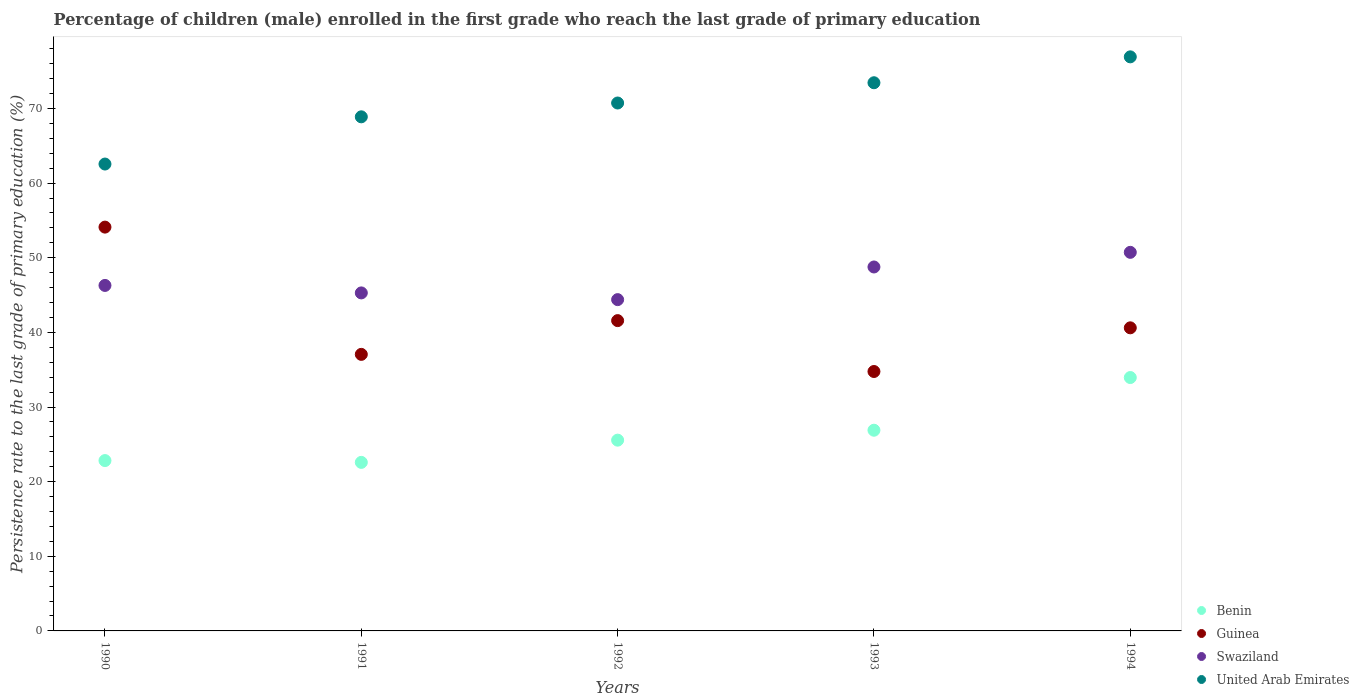Is the number of dotlines equal to the number of legend labels?
Your answer should be very brief. Yes. What is the persistence rate of children in Guinea in 1994?
Provide a short and direct response. 40.61. Across all years, what is the maximum persistence rate of children in Swaziland?
Your answer should be very brief. 50.73. Across all years, what is the minimum persistence rate of children in United Arab Emirates?
Give a very brief answer. 62.56. What is the total persistence rate of children in Swaziland in the graph?
Provide a short and direct response. 235.47. What is the difference between the persistence rate of children in Benin in 1991 and that in 1994?
Provide a short and direct response. -11.37. What is the difference between the persistence rate of children in Guinea in 1991 and the persistence rate of children in Benin in 1992?
Provide a succinct answer. 11.49. What is the average persistence rate of children in Swaziland per year?
Offer a terse response. 47.09. In the year 1992, what is the difference between the persistence rate of children in United Arab Emirates and persistence rate of children in Swaziland?
Ensure brevity in your answer.  26.35. In how many years, is the persistence rate of children in Guinea greater than 38 %?
Make the answer very short. 3. What is the ratio of the persistence rate of children in United Arab Emirates in 1990 to that in 1991?
Provide a succinct answer. 0.91. Is the difference between the persistence rate of children in United Arab Emirates in 1990 and 1994 greater than the difference between the persistence rate of children in Swaziland in 1990 and 1994?
Ensure brevity in your answer.  No. What is the difference between the highest and the second highest persistence rate of children in Swaziland?
Provide a short and direct response. 1.96. What is the difference between the highest and the lowest persistence rate of children in Swaziland?
Provide a short and direct response. 6.34. In how many years, is the persistence rate of children in Guinea greater than the average persistence rate of children in Guinea taken over all years?
Offer a very short reply. 1. Is it the case that in every year, the sum of the persistence rate of children in United Arab Emirates and persistence rate of children in Swaziland  is greater than the persistence rate of children in Guinea?
Provide a succinct answer. Yes. Does the persistence rate of children in Benin monotonically increase over the years?
Provide a succinct answer. No. Is the persistence rate of children in United Arab Emirates strictly less than the persistence rate of children in Swaziland over the years?
Offer a very short reply. No. How many years are there in the graph?
Your answer should be very brief. 5. Does the graph contain grids?
Your response must be concise. No. Where does the legend appear in the graph?
Your response must be concise. Bottom right. How are the legend labels stacked?
Your answer should be compact. Vertical. What is the title of the graph?
Ensure brevity in your answer.  Percentage of children (male) enrolled in the first grade who reach the last grade of primary education. What is the label or title of the X-axis?
Your answer should be very brief. Years. What is the label or title of the Y-axis?
Your response must be concise. Persistence rate to the last grade of primary education (%). What is the Persistence rate to the last grade of primary education (%) in Benin in 1990?
Ensure brevity in your answer.  22.82. What is the Persistence rate to the last grade of primary education (%) of Guinea in 1990?
Keep it short and to the point. 54.11. What is the Persistence rate to the last grade of primary education (%) of Swaziland in 1990?
Your answer should be compact. 46.29. What is the Persistence rate to the last grade of primary education (%) of United Arab Emirates in 1990?
Your answer should be very brief. 62.56. What is the Persistence rate to the last grade of primary education (%) in Benin in 1991?
Your answer should be very brief. 22.58. What is the Persistence rate to the last grade of primary education (%) of Guinea in 1991?
Make the answer very short. 37.06. What is the Persistence rate to the last grade of primary education (%) in Swaziland in 1991?
Provide a short and direct response. 45.29. What is the Persistence rate to the last grade of primary education (%) in United Arab Emirates in 1991?
Offer a terse response. 68.89. What is the Persistence rate to the last grade of primary education (%) in Benin in 1992?
Your answer should be compact. 25.56. What is the Persistence rate to the last grade of primary education (%) of Guinea in 1992?
Offer a very short reply. 41.58. What is the Persistence rate to the last grade of primary education (%) of Swaziland in 1992?
Offer a very short reply. 44.39. What is the Persistence rate to the last grade of primary education (%) of United Arab Emirates in 1992?
Offer a terse response. 70.74. What is the Persistence rate to the last grade of primary education (%) in Benin in 1993?
Give a very brief answer. 26.89. What is the Persistence rate to the last grade of primary education (%) of Guinea in 1993?
Keep it short and to the point. 34.76. What is the Persistence rate to the last grade of primary education (%) in Swaziland in 1993?
Provide a succinct answer. 48.76. What is the Persistence rate to the last grade of primary education (%) in United Arab Emirates in 1993?
Offer a terse response. 73.45. What is the Persistence rate to the last grade of primary education (%) in Benin in 1994?
Offer a terse response. 33.95. What is the Persistence rate to the last grade of primary education (%) of Guinea in 1994?
Keep it short and to the point. 40.61. What is the Persistence rate to the last grade of primary education (%) in Swaziland in 1994?
Your response must be concise. 50.73. What is the Persistence rate to the last grade of primary education (%) in United Arab Emirates in 1994?
Provide a short and direct response. 76.92. Across all years, what is the maximum Persistence rate to the last grade of primary education (%) in Benin?
Keep it short and to the point. 33.95. Across all years, what is the maximum Persistence rate to the last grade of primary education (%) in Guinea?
Your response must be concise. 54.11. Across all years, what is the maximum Persistence rate to the last grade of primary education (%) of Swaziland?
Keep it short and to the point. 50.73. Across all years, what is the maximum Persistence rate to the last grade of primary education (%) in United Arab Emirates?
Provide a succinct answer. 76.92. Across all years, what is the minimum Persistence rate to the last grade of primary education (%) of Benin?
Offer a terse response. 22.58. Across all years, what is the minimum Persistence rate to the last grade of primary education (%) in Guinea?
Make the answer very short. 34.76. Across all years, what is the minimum Persistence rate to the last grade of primary education (%) in Swaziland?
Your answer should be compact. 44.39. Across all years, what is the minimum Persistence rate to the last grade of primary education (%) in United Arab Emirates?
Offer a very short reply. 62.56. What is the total Persistence rate to the last grade of primary education (%) in Benin in the graph?
Ensure brevity in your answer.  131.81. What is the total Persistence rate to the last grade of primary education (%) in Guinea in the graph?
Your answer should be compact. 208.11. What is the total Persistence rate to the last grade of primary education (%) in Swaziland in the graph?
Your answer should be compact. 235.47. What is the total Persistence rate to the last grade of primary education (%) of United Arab Emirates in the graph?
Make the answer very short. 352.55. What is the difference between the Persistence rate to the last grade of primary education (%) of Benin in 1990 and that in 1991?
Your response must be concise. 0.24. What is the difference between the Persistence rate to the last grade of primary education (%) of Guinea in 1990 and that in 1991?
Keep it short and to the point. 17.05. What is the difference between the Persistence rate to the last grade of primary education (%) in United Arab Emirates in 1990 and that in 1991?
Provide a succinct answer. -6.33. What is the difference between the Persistence rate to the last grade of primary education (%) of Benin in 1990 and that in 1992?
Offer a terse response. -2.74. What is the difference between the Persistence rate to the last grade of primary education (%) in Guinea in 1990 and that in 1992?
Your answer should be very brief. 12.53. What is the difference between the Persistence rate to the last grade of primary education (%) of Swaziland in 1990 and that in 1992?
Your answer should be compact. 1.9. What is the difference between the Persistence rate to the last grade of primary education (%) of United Arab Emirates in 1990 and that in 1992?
Provide a short and direct response. -8.18. What is the difference between the Persistence rate to the last grade of primary education (%) in Benin in 1990 and that in 1993?
Give a very brief answer. -4.07. What is the difference between the Persistence rate to the last grade of primary education (%) in Guinea in 1990 and that in 1993?
Offer a very short reply. 19.35. What is the difference between the Persistence rate to the last grade of primary education (%) of Swaziland in 1990 and that in 1993?
Keep it short and to the point. -2.47. What is the difference between the Persistence rate to the last grade of primary education (%) in United Arab Emirates in 1990 and that in 1993?
Your response must be concise. -10.89. What is the difference between the Persistence rate to the last grade of primary education (%) of Benin in 1990 and that in 1994?
Provide a short and direct response. -11.13. What is the difference between the Persistence rate to the last grade of primary education (%) in Guinea in 1990 and that in 1994?
Offer a terse response. 13.49. What is the difference between the Persistence rate to the last grade of primary education (%) in Swaziland in 1990 and that in 1994?
Make the answer very short. -4.44. What is the difference between the Persistence rate to the last grade of primary education (%) of United Arab Emirates in 1990 and that in 1994?
Offer a terse response. -14.36. What is the difference between the Persistence rate to the last grade of primary education (%) in Benin in 1991 and that in 1992?
Offer a very short reply. -2.98. What is the difference between the Persistence rate to the last grade of primary education (%) of Guinea in 1991 and that in 1992?
Ensure brevity in your answer.  -4.52. What is the difference between the Persistence rate to the last grade of primary education (%) of Swaziland in 1991 and that in 1992?
Give a very brief answer. 0.9. What is the difference between the Persistence rate to the last grade of primary education (%) of United Arab Emirates in 1991 and that in 1992?
Offer a very short reply. -1.85. What is the difference between the Persistence rate to the last grade of primary education (%) in Benin in 1991 and that in 1993?
Make the answer very short. -4.31. What is the difference between the Persistence rate to the last grade of primary education (%) in Guinea in 1991 and that in 1993?
Your answer should be compact. 2.3. What is the difference between the Persistence rate to the last grade of primary education (%) in Swaziland in 1991 and that in 1993?
Provide a succinct answer. -3.47. What is the difference between the Persistence rate to the last grade of primary education (%) in United Arab Emirates in 1991 and that in 1993?
Keep it short and to the point. -4.57. What is the difference between the Persistence rate to the last grade of primary education (%) of Benin in 1991 and that in 1994?
Provide a short and direct response. -11.37. What is the difference between the Persistence rate to the last grade of primary education (%) in Guinea in 1991 and that in 1994?
Give a very brief answer. -3.56. What is the difference between the Persistence rate to the last grade of primary education (%) in Swaziland in 1991 and that in 1994?
Keep it short and to the point. -5.44. What is the difference between the Persistence rate to the last grade of primary education (%) in United Arab Emirates in 1991 and that in 1994?
Offer a terse response. -8.04. What is the difference between the Persistence rate to the last grade of primary education (%) of Benin in 1992 and that in 1993?
Offer a very short reply. -1.33. What is the difference between the Persistence rate to the last grade of primary education (%) in Guinea in 1992 and that in 1993?
Offer a terse response. 6.82. What is the difference between the Persistence rate to the last grade of primary education (%) of Swaziland in 1992 and that in 1993?
Your answer should be very brief. -4.37. What is the difference between the Persistence rate to the last grade of primary education (%) in United Arab Emirates in 1992 and that in 1993?
Offer a terse response. -2.71. What is the difference between the Persistence rate to the last grade of primary education (%) in Benin in 1992 and that in 1994?
Make the answer very short. -8.39. What is the difference between the Persistence rate to the last grade of primary education (%) of Guinea in 1992 and that in 1994?
Your answer should be compact. 0.97. What is the difference between the Persistence rate to the last grade of primary education (%) in Swaziland in 1992 and that in 1994?
Offer a terse response. -6.34. What is the difference between the Persistence rate to the last grade of primary education (%) in United Arab Emirates in 1992 and that in 1994?
Your answer should be compact. -6.18. What is the difference between the Persistence rate to the last grade of primary education (%) in Benin in 1993 and that in 1994?
Make the answer very short. -7.06. What is the difference between the Persistence rate to the last grade of primary education (%) in Guinea in 1993 and that in 1994?
Keep it short and to the point. -5.85. What is the difference between the Persistence rate to the last grade of primary education (%) in Swaziland in 1993 and that in 1994?
Provide a short and direct response. -1.96. What is the difference between the Persistence rate to the last grade of primary education (%) of United Arab Emirates in 1993 and that in 1994?
Your response must be concise. -3.47. What is the difference between the Persistence rate to the last grade of primary education (%) in Benin in 1990 and the Persistence rate to the last grade of primary education (%) in Guinea in 1991?
Your answer should be very brief. -14.23. What is the difference between the Persistence rate to the last grade of primary education (%) of Benin in 1990 and the Persistence rate to the last grade of primary education (%) of Swaziland in 1991?
Give a very brief answer. -22.47. What is the difference between the Persistence rate to the last grade of primary education (%) of Benin in 1990 and the Persistence rate to the last grade of primary education (%) of United Arab Emirates in 1991?
Give a very brief answer. -46.06. What is the difference between the Persistence rate to the last grade of primary education (%) of Guinea in 1990 and the Persistence rate to the last grade of primary education (%) of Swaziland in 1991?
Make the answer very short. 8.82. What is the difference between the Persistence rate to the last grade of primary education (%) of Guinea in 1990 and the Persistence rate to the last grade of primary education (%) of United Arab Emirates in 1991?
Your answer should be compact. -14.78. What is the difference between the Persistence rate to the last grade of primary education (%) in Swaziland in 1990 and the Persistence rate to the last grade of primary education (%) in United Arab Emirates in 1991?
Your answer should be compact. -22.59. What is the difference between the Persistence rate to the last grade of primary education (%) of Benin in 1990 and the Persistence rate to the last grade of primary education (%) of Guinea in 1992?
Provide a short and direct response. -18.75. What is the difference between the Persistence rate to the last grade of primary education (%) in Benin in 1990 and the Persistence rate to the last grade of primary education (%) in Swaziland in 1992?
Keep it short and to the point. -21.57. What is the difference between the Persistence rate to the last grade of primary education (%) in Benin in 1990 and the Persistence rate to the last grade of primary education (%) in United Arab Emirates in 1992?
Make the answer very short. -47.91. What is the difference between the Persistence rate to the last grade of primary education (%) in Guinea in 1990 and the Persistence rate to the last grade of primary education (%) in Swaziland in 1992?
Provide a short and direct response. 9.72. What is the difference between the Persistence rate to the last grade of primary education (%) of Guinea in 1990 and the Persistence rate to the last grade of primary education (%) of United Arab Emirates in 1992?
Offer a terse response. -16.63. What is the difference between the Persistence rate to the last grade of primary education (%) of Swaziland in 1990 and the Persistence rate to the last grade of primary education (%) of United Arab Emirates in 1992?
Offer a terse response. -24.44. What is the difference between the Persistence rate to the last grade of primary education (%) in Benin in 1990 and the Persistence rate to the last grade of primary education (%) in Guinea in 1993?
Provide a short and direct response. -11.94. What is the difference between the Persistence rate to the last grade of primary education (%) of Benin in 1990 and the Persistence rate to the last grade of primary education (%) of Swaziland in 1993?
Keep it short and to the point. -25.94. What is the difference between the Persistence rate to the last grade of primary education (%) of Benin in 1990 and the Persistence rate to the last grade of primary education (%) of United Arab Emirates in 1993?
Give a very brief answer. -50.63. What is the difference between the Persistence rate to the last grade of primary education (%) in Guinea in 1990 and the Persistence rate to the last grade of primary education (%) in Swaziland in 1993?
Your response must be concise. 5.34. What is the difference between the Persistence rate to the last grade of primary education (%) of Guinea in 1990 and the Persistence rate to the last grade of primary education (%) of United Arab Emirates in 1993?
Keep it short and to the point. -19.34. What is the difference between the Persistence rate to the last grade of primary education (%) of Swaziland in 1990 and the Persistence rate to the last grade of primary education (%) of United Arab Emirates in 1993?
Give a very brief answer. -27.16. What is the difference between the Persistence rate to the last grade of primary education (%) of Benin in 1990 and the Persistence rate to the last grade of primary education (%) of Guinea in 1994?
Provide a succinct answer. -17.79. What is the difference between the Persistence rate to the last grade of primary education (%) in Benin in 1990 and the Persistence rate to the last grade of primary education (%) in Swaziland in 1994?
Your answer should be very brief. -27.9. What is the difference between the Persistence rate to the last grade of primary education (%) of Benin in 1990 and the Persistence rate to the last grade of primary education (%) of United Arab Emirates in 1994?
Ensure brevity in your answer.  -54.1. What is the difference between the Persistence rate to the last grade of primary education (%) of Guinea in 1990 and the Persistence rate to the last grade of primary education (%) of Swaziland in 1994?
Provide a succinct answer. 3.38. What is the difference between the Persistence rate to the last grade of primary education (%) in Guinea in 1990 and the Persistence rate to the last grade of primary education (%) in United Arab Emirates in 1994?
Make the answer very short. -22.81. What is the difference between the Persistence rate to the last grade of primary education (%) in Swaziland in 1990 and the Persistence rate to the last grade of primary education (%) in United Arab Emirates in 1994?
Offer a very short reply. -30.63. What is the difference between the Persistence rate to the last grade of primary education (%) in Benin in 1991 and the Persistence rate to the last grade of primary education (%) in Guinea in 1992?
Your answer should be compact. -18.99. What is the difference between the Persistence rate to the last grade of primary education (%) of Benin in 1991 and the Persistence rate to the last grade of primary education (%) of Swaziland in 1992?
Ensure brevity in your answer.  -21.81. What is the difference between the Persistence rate to the last grade of primary education (%) in Benin in 1991 and the Persistence rate to the last grade of primary education (%) in United Arab Emirates in 1992?
Give a very brief answer. -48.15. What is the difference between the Persistence rate to the last grade of primary education (%) in Guinea in 1991 and the Persistence rate to the last grade of primary education (%) in Swaziland in 1992?
Ensure brevity in your answer.  -7.34. What is the difference between the Persistence rate to the last grade of primary education (%) in Guinea in 1991 and the Persistence rate to the last grade of primary education (%) in United Arab Emirates in 1992?
Provide a short and direct response. -33.68. What is the difference between the Persistence rate to the last grade of primary education (%) in Swaziland in 1991 and the Persistence rate to the last grade of primary education (%) in United Arab Emirates in 1992?
Provide a short and direct response. -25.45. What is the difference between the Persistence rate to the last grade of primary education (%) of Benin in 1991 and the Persistence rate to the last grade of primary education (%) of Guinea in 1993?
Your answer should be compact. -12.18. What is the difference between the Persistence rate to the last grade of primary education (%) in Benin in 1991 and the Persistence rate to the last grade of primary education (%) in Swaziland in 1993?
Give a very brief answer. -26.18. What is the difference between the Persistence rate to the last grade of primary education (%) in Benin in 1991 and the Persistence rate to the last grade of primary education (%) in United Arab Emirates in 1993?
Your answer should be compact. -50.87. What is the difference between the Persistence rate to the last grade of primary education (%) in Guinea in 1991 and the Persistence rate to the last grade of primary education (%) in Swaziland in 1993?
Ensure brevity in your answer.  -11.71. What is the difference between the Persistence rate to the last grade of primary education (%) of Guinea in 1991 and the Persistence rate to the last grade of primary education (%) of United Arab Emirates in 1993?
Your answer should be very brief. -36.4. What is the difference between the Persistence rate to the last grade of primary education (%) of Swaziland in 1991 and the Persistence rate to the last grade of primary education (%) of United Arab Emirates in 1993?
Provide a short and direct response. -28.16. What is the difference between the Persistence rate to the last grade of primary education (%) in Benin in 1991 and the Persistence rate to the last grade of primary education (%) in Guinea in 1994?
Make the answer very short. -18.03. What is the difference between the Persistence rate to the last grade of primary education (%) in Benin in 1991 and the Persistence rate to the last grade of primary education (%) in Swaziland in 1994?
Your answer should be compact. -28.14. What is the difference between the Persistence rate to the last grade of primary education (%) of Benin in 1991 and the Persistence rate to the last grade of primary education (%) of United Arab Emirates in 1994?
Offer a terse response. -54.34. What is the difference between the Persistence rate to the last grade of primary education (%) in Guinea in 1991 and the Persistence rate to the last grade of primary education (%) in Swaziland in 1994?
Provide a succinct answer. -13.67. What is the difference between the Persistence rate to the last grade of primary education (%) in Guinea in 1991 and the Persistence rate to the last grade of primary education (%) in United Arab Emirates in 1994?
Provide a succinct answer. -39.87. What is the difference between the Persistence rate to the last grade of primary education (%) of Swaziland in 1991 and the Persistence rate to the last grade of primary education (%) of United Arab Emirates in 1994?
Provide a short and direct response. -31.63. What is the difference between the Persistence rate to the last grade of primary education (%) of Benin in 1992 and the Persistence rate to the last grade of primary education (%) of Guinea in 1993?
Your response must be concise. -9.2. What is the difference between the Persistence rate to the last grade of primary education (%) in Benin in 1992 and the Persistence rate to the last grade of primary education (%) in Swaziland in 1993?
Provide a succinct answer. -23.2. What is the difference between the Persistence rate to the last grade of primary education (%) of Benin in 1992 and the Persistence rate to the last grade of primary education (%) of United Arab Emirates in 1993?
Offer a terse response. -47.89. What is the difference between the Persistence rate to the last grade of primary education (%) of Guinea in 1992 and the Persistence rate to the last grade of primary education (%) of Swaziland in 1993?
Your answer should be compact. -7.19. What is the difference between the Persistence rate to the last grade of primary education (%) in Guinea in 1992 and the Persistence rate to the last grade of primary education (%) in United Arab Emirates in 1993?
Your answer should be compact. -31.87. What is the difference between the Persistence rate to the last grade of primary education (%) of Swaziland in 1992 and the Persistence rate to the last grade of primary education (%) of United Arab Emirates in 1993?
Your answer should be compact. -29.06. What is the difference between the Persistence rate to the last grade of primary education (%) in Benin in 1992 and the Persistence rate to the last grade of primary education (%) in Guinea in 1994?
Offer a very short reply. -15.05. What is the difference between the Persistence rate to the last grade of primary education (%) of Benin in 1992 and the Persistence rate to the last grade of primary education (%) of Swaziland in 1994?
Make the answer very short. -25.17. What is the difference between the Persistence rate to the last grade of primary education (%) of Benin in 1992 and the Persistence rate to the last grade of primary education (%) of United Arab Emirates in 1994?
Your answer should be very brief. -51.36. What is the difference between the Persistence rate to the last grade of primary education (%) in Guinea in 1992 and the Persistence rate to the last grade of primary education (%) in Swaziland in 1994?
Your answer should be compact. -9.15. What is the difference between the Persistence rate to the last grade of primary education (%) in Guinea in 1992 and the Persistence rate to the last grade of primary education (%) in United Arab Emirates in 1994?
Your answer should be very brief. -35.34. What is the difference between the Persistence rate to the last grade of primary education (%) in Swaziland in 1992 and the Persistence rate to the last grade of primary education (%) in United Arab Emirates in 1994?
Make the answer very short. -32.53. What is the difference between the Persistence rate to the last grade of primary education (%) of Benin in 1993 and the Persistence rate to the last grade of primary education (%) of Guinea in 1994?
Your response must be concise. -13.72. What is the difference between the Persistence rate to the last grade of primary education (%) in Benin in 1993 and the Persistence rate to the last grade of primary education (%) in Swaziland in 1994?
Your answer should be very brief. -23.84. What is the difference between the Persistence rate to the last grade of primary education (%) in Benin in 1993 and the Persistence rate to the last grade of primary education (%) in United Arab Emirates in 1994?
Give a very brief answer. -50.03. What is the difference between the Persistence rate to the last grade of primary education (%) of Guinea in 1993 and the Persistence rate to the last grade of primary education (%) of Swaziland in 1994?
Provide a short and direct response. -15.97. What is the difference between the Persistence rate to the last grade of primary education (%) of Guinea in 1993 and the Persistence rate to the last grade of primary education (%) of United Arab Emirates in 1994?
Provide a succinct answer. -42.16. What is the difference between the Persistence rate to the last grade of primary education (%) in Swaziland in 1993 and the Persistence rate to the last grade of primary education (%) in United Arab Emirates in 1994?
Offer a terse response. -28.16. What is the average Persistence rate to the last grade of primary education (%) of Benin per year?
Give a very brief answer. 26.36. What is the average Persistence rate to the last grade of primary education (%) in Guinea per year?
Your response must be concise. 41.62. What is the average Persistence rate to the last grade of primary education (%) of Swaziland per year?
Ensure brevity in your answer.  47.09. What is the average Persistence rate to the last grade of primary education (%) in United Arab Emirates per year?
Provide a short and direct response. 70.51. In the year 1990, what is the difference between the Persistence rate to the last grade of primary education (%) in Benin and Persistence rate to the last grade of primary education (%) in Guinea?
Make the answer very short. -31.28. In the year 1990, what is the difference between the Persistence rate to the last grade of primary education (%) of Benin and Persistence rate to the last grade of primary education (%) of Swaziland?
Make the answer very short. -23.47. In the year 1990, what is the difference between the Persistence rate to the last grade of primary education (%) of Benin and Persistence rate to the last grade of primary education (%) of United Arab Emirates?
Ensure brevity in your answer.  -39.73. In the year 1990, what is the difference between the Persistence rate to the last grade of primary education (%) in Guinea and Persistence rate to the last grade of primary education (%) in Swaziland?
Make the answer very short. 7.81. In the year 1990, what is the difference between the Persistence rate to the last grade of primary education (%) in Guinea and Persistence rate to the last grade of primary education (%) in United Arab Emirates?
Offer a terse response. -8.45. In the year 1990, what is the difference between the Persistence rate to the last grade of primary education (%) of Swaziland and Persistence rate to the last grade of primary education (%) of United Arab Emirates?
Provide a succinct answer. -16.27. In the year 1991, what is the difference between the Persistence rate to the last grade of primary education (%) in Benin and Persistence rate to the last grade of primary education (%) in Guinea?
Make the answer very short. -14.47. In the year 1991, what is the difference between the Persistence rate to the last grade of primary education (%) of Benin and Persistence rate to the last grade of primary education (%) of Swaziland?
Your answer should be compact. -22.71. In the year 1991, what is the difference between the Persistence rate to the last grade of primary education (%) of Benin and Persistence rate to the last grade of primary education (%) of United Arab Emirates?
Provide a short and direct response. -46.3. In the year 1991, what is the difference between the Persistence rate to the last grade of primary education (%) of Guinea and Persistence rate to the last grade of primary education (%) of Swaziland?
Your response must be concise. -8.24. In the year 1991, what is the difference between the Persistence rate to the last grade of primary education (%) in Guinea and Persistence rate to the last grade of primary education (%) in United Arab Emirates?
Offer a very short reply. -31.83. In the year 1991, what is the difference between the Persistence rate to the last grade of primary education (%) in Swaziland and Persistence rate to the last grade of primary education (%) in United Arab Emirates?
Your answer should be compact. -23.59. In the year 1992, what is the difference between the Persistence rate to the last grade of primary education (%) of Benin and Persistence rate to the last grade of primary education (%) of Guinea?
Ensure brevity in your answer.  -16.02. In the year 1992, what is the difference between the Persistence rate to the last grade of primary education (%) of Benin and Persistence rate to the last grade of primary education (%) of Swaziland?
Ensure brevity in your answer.  -18.83. In the year 1992, what is the difference between the Persistence rate to the last grade of primary education (%) in Benin and Persistence rate to the last grade of primary education (%) in United Arab Emirates?
Offer a very short reply. -45.17. In the year 1992, what is the difference between the Persistence rate to the last grade of primary education (%) of Guinea and Persistence rate to the last grade of primary education (%) of Swaziland?
Offer a terse response. -2.81. In the year 1992, what is the difference between the Persistence rate to the last grade of primary education (%) in Guinea and Persistence rate to the last grade of primary education (%) in United Arab Emirates?
Offer a very short reply. -29.16. In the year 1992, what is the difference between the Persistence rate to the last grade of primary education (%) in Swaziland and Persistence rate to the last grade of primary education (%) in United Arab Emirates?
Make the answer very short. -26.35. In the year 1993, what is the difference between the Persistence rate to the last grade of primary education (%) of Benin and Persistence rate to the last grade of primary education (%) of Guinea?
Provide a short and direct response. -7.87. In the year 1993, what is the difference between the Persistence rate to the last grade of primary education (%) of Benin and Persistence rate to the last grade of primary education (%) of Swaziland?
Make the answer very short. -21.87. In the year 1993, what is the difference between the Persistence rate to the last grade of primary education (%) in Benin and Persistence rate to the last grade of primary education (%) in United Arab Emirates?
Your answer should be compact. -46.56. In the year 1993, what is the difference between the Persistence rate to the last grade of primary education (%) of Guinea and Persistence rate to the last grade of primary education (%) of Swaziland?
Make the answer very short. -14. In the year 1993, what is the difference between the Persistence rate to the last grade of primary education (%) of Guinea and Persistence rate to the last grade of primary education (%) of United Arab Emirates?
Ensure brevity in your answer.  -38.69. In the year 1993, what is the difference between the Persistence rate to the last grade of primary education (%) in Swaziland and Persistence rate to the last grade of primary education (%) in United Arab Emirates?
Make the answer very short. -24.69. In the year 1994, what is the difference between the Persistence rate to the last grade of primary education (%) of Benin and Persistence rate to the last grade of primary education (%) of Guinea?
Offer a terse response. -6.66. In the year 1994, what is the difference between the Persistence rate to the last grade of primary education (%) of Benin and Persistence rate to the last grade of primary education (%) of Swaziland?
Give a very brief answer. -16.78. In the year 1994, what is the difference between the Persistence rate to the last grade of primary education (%) of Benin and Persistence rate to the last grade of primary education (%) of United Arab Emirates?
Ensure brevity in your answer.  -42.97. In the year 1994, what is the difference between the Persistence rate to the last grade of primary education (%) in Guinea and Persistence rate to the last grade of primary education (%) in Swaziland?
Offer a very short reply. -10.12. In the year 1994, what is the difference between the Persistence rate to the last grade of primary education (%) in Guinea and Persistence rate to the last grade of primary education (%) in United Arab Emirates?
Provide a short and direct response. -36.31. In the year 1994, what is the difference between the Persistence rate to the last grade of primary education (%) in Swaziland and Persistence rate to the last grade of primary education (%) in United Arab Emirates?
Your answer should be compact. -26.19. What is the ratio of the Persistence rate to the last grade of primary education (%) in Benin in 1990 to that in 1991?
Keep it short and to the point. 1.01. What is the ratio of the Persistence rate to the last grade of primary education (%) of Guinea in 1990 to that in 1991?
Your answer should be compact. 1.46. What is the ratio of the Persistence rate to the last grade of primary education (%) of Swaziland in 1990 to that in 1991?
Your answer should be compact. 1.02. What is the ratio of the Persistence rate to the last grade of primary education (%) in United Arab Emirates in 1990 to that in 1991?
Ensure brevity in your answer.  0.91. What is the ratio of the Persistence rate to the last grade of primary education (%) of Benin in 1990 to that in 1992?
Provide a succinct answer. 0.89. What is the ratio of the Persistence rate to the last grade of primary education (%) of Guinea in 1990 to that in 1992?
Your answer should be very brief. 1.3. What is the ratio of the Persistence rate to the last grade of primary education (%) of Swaziland in 1990 to that in 1992?
Your answer should be very brief. 1.04. What is the ratio of the Persistence rate to the last grade of primary education (%) of United Arab Emirates in 1990 to that in 1992?
Provide a short and direct response. 0.88. What is the ratio of the Persistence rate to the last grade of primary education (%) of Benin in 1990 to that in 1993?
Keep it short and to the point. 0.85. What is the ratio of the Persistence rate to the last grade of primary education (%) in Guinea in 1990 to that in 1993?
Offer a very short reply. 1.56. What is the ratio of the Persistence rate to the last grade of primary education (%) in Swaziland in 1990 to that in 1993?
Offer a very short reply. 0.95. What is the ratio of the Persistence rate to the last grade of primary education (%) of United Arab Emirates in 1990 to that in 1993?
Keep it short and to the point. 0.85. What is the ratio of the Persistence rate to the last grade of primary education (%) in Benin in 1990 to that in 1994?
Offer a terse response. 0.67. What is the ratio of the Persistence rate to the last grade of primary education (%) of Guinea in 1990 to that in 1994?
Make the answer very short. 1.33. What is the ratio of the Persistence rate to the last grade of primary education (%) in Swaziland in 1990 to that in 1994?
Your answer should be compact. 0.91. What is the ratio of the Persistence rate to the last grade of primary education (%) of United Arab Emirates in 1990 to that in 1994?
Offer a terse response. 0.81. What is the ratio of the Persistence rate to the last grade of primary education (%) in Benin in 1991 to that in 1992?
Ensure brevity in your answer.  0.88. What is the ratio of the Persistence rate to the last grade of primary education (%) in Guinea in 1991 to that in 1992?
Offer a very short reply. 0.89. What is the ratio of the Persistence rate to the last grade of primary education (%) of Swaziland in 1991 to that in 1992?
Your response must be concise. 1.02. What is the ratio of the Persistence rate to the last grade of primary education (%) of United Arab Emirates in 1991 to that in 1992?
Your response must be concise. 0.97. What is the ratio of the Persistence rate to the last grade of primary education (%) in Benin in 1991 to that in 1993?
Your answer should be compact. 0.84. What is the ratio of the Persistence rate to the last grade of primary education (%) of Guinea in 1991 to that in 1993?
Your answer should be very brief. 1.07. What is the ratio of the Persistence rate to the last grade of primary education (%) in Swaziland in 1991 to that in 1993?
Provide a succinct answer. 0.93. What is the ratio of the Persistence rate to the last grade of primary education (%) in United Arab Emirates in 1991 to that in 1993?
Make the answer very short. 0.94. What is the ratio of the Persistence rate to the last grade of primary education (%) of Benin in 1991 to that in 1994?
Offer a terse response. 0.67. What is the ratio of the Persistence rate to the last grade of primary education (%) in Guinea in 1991 to that in 1994?
Offer a terse response. 0.91. What is the ratio of the Persistence rate to the last grade of primary education (%) of Swaziland in 1991 to that in 1994?
Provide a short and direct response. 0.89. What is the ratio of the Persistence rate to the last grade of primary education (%) in United Arab Emirates in 1991 to that in 1994?
Offer a terse response. 0.9. What is the ratio of the Persistence rate to the last grade of primary education (%) in Benin in 1992 to that in 1993?
Your answer should be very brief. 0.95. What is the ratio of the Persistence rate to the last grade of primary education (%) of Guinea in 1992 to that in 1993?
Your answer should be compact. 1.2. What is the ratio of the Persistence rate to the last grade of primary education (%) of Swaziland in 1992 to that in 1993?
Make the answer very short. 0.91. What is the ratio of the Persistence rate to the last grade of primary education (%) of Benin in 1992 to that in 1994?
Your answer should be very brief. 0.75. What is the ratio of the Persistence rate to the last grade of primary education (%) of Guinea in 1992 to that in 1994?
Offer a terse response. 1.02. What is the ratio of the Persistence rate to the last grade of primary education (%) in Swaziland in 1992 to that in 1994?
Offer a terse response. 0.88. What is the ratio of the Persistence rate to the last grade of primary education (%) in United Arab Emirates in 1992 to that in 1994?
Your answer should be compact. 0.92. What is the ratio of the Persistence rate to the last grade of primary education (%) of Benin in 1993 to that in 1994?
Provide a short and direct response. 0.79. What is the ratio of the Persistence rate to the last grade of primary education (%) of Guinea in 1993 to that in 1994?
Provide a succinct answer. 0.86. What is the ratio of the Persistence rate to the last grade of primary education (%) in Swaziland in 1993 to that in 1994?
Make the answer very short. 0.96. What is the ratio of the Persistence rate to the last grade of primary education (%) of United Arab Emirates in 1993 to that in 1994?
Keep it short and to the point. 0.95. What is the difference between the highest and the second highest Persistence rate to the last grade of primary education (%) of Benin?
Give a very brief answer. 7.06. What is the difference between the highest and the second highest Persistence rate to the last grade of primary education (%) in Guinea?
Make the answer very short. 12.53. What is the difference between the highest and the second highest Persistence rate to the last grade of primary education (%) of Swaziland?
Your answer should be very brief. 1.96. What is the difference between the highest and the second highest Persistence rate to the last grade of primary education (%) of United Arab Emirates?
Your answer should be very brief. 3.47. What is the difference between the highest and the lowest Persistence rate to the last grade of primary education (%) in Benin?
Your response must be concise. 11.37. What is the difference between the highest and the lowest Persistence rate to the last grade of primary education (%) in Guinea?
Your answer should be compact. 19.35. What is the difference between the highest and the lowest Persistence rate to the last grade of primary education (%) of Swaziland?
Your answer should be compact. 6.34. What is the difference between the highest and the lowest Persistence rate to the last grade of primary education (%) of United Arab Emirates?
Ensure brevity in your answer.  14.36. 